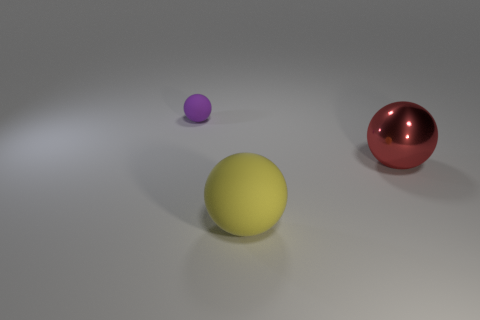Are there more big yellow matte things than yellow metallic cylinders?
Provide a succinct answer. Yes. What number of objects are either matte objects to the right of the purple rubber sphere or metallic balls?
Keep it short and to the point. 2. There is a large thing behind the big yellow thing; what number of shiny balls are behind it?
Offer a very short reply. 0. What is the size of the rubber sphere that is behind the big thing behind the matte ball that is in front of the tiny ball?
Your answer should be very brief. Small. There is a rubber ball behind the red metallic sphere; is it the same color as the metal sphere?
Your response must be concise. No. There is another yellow rubber thing that is the same shape as the tiny rubber thing; what size is it?
Your response must be concise. Large. How many things are yellow rubber things on the left side of the red object or big things that are in front of the big red object?
Keep it short and to the point. 1. What is the shape of the matte object that is in front of the matte sphere that is behind the shiny ball?
Your response must be concise. Sphere. Are there any other things that have the same color as the small matte sphere?
Provide a succinct answer. No. Is there any other thing that has the same size as the yellow ball?
Your response must be concise. Yes. 